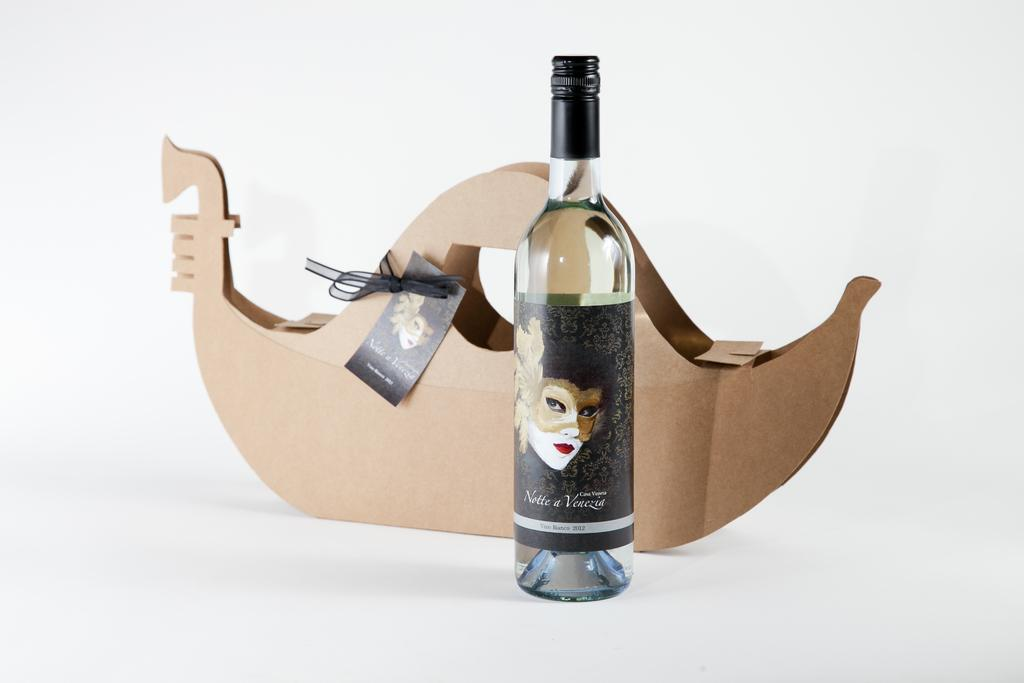<image>
Relay a brief, clear account of the picture shown. a bottle of Notte a Venezia wine in front of a gondola shaped carrying case 